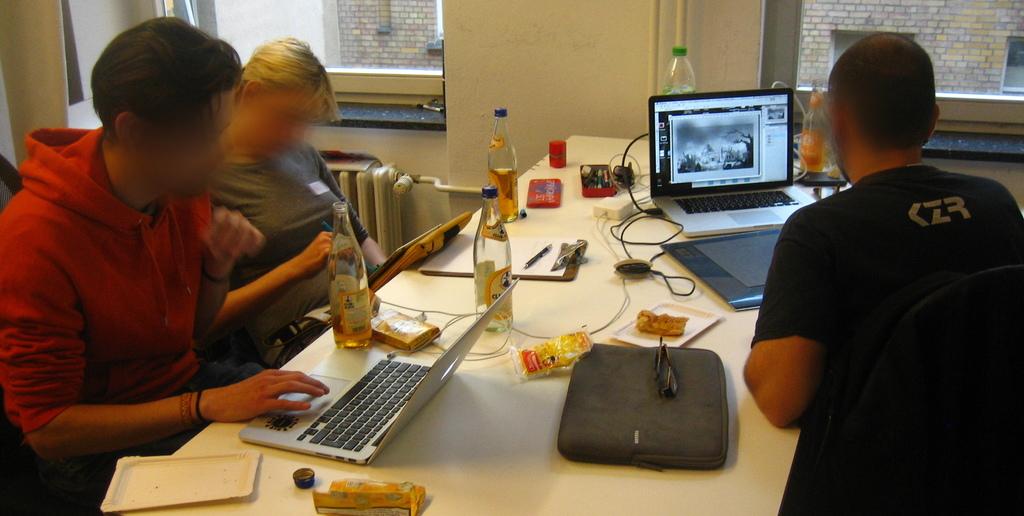What is written on the back of the shirt on the guy on the right?
Ensure brevity in your answer.  Czr. 